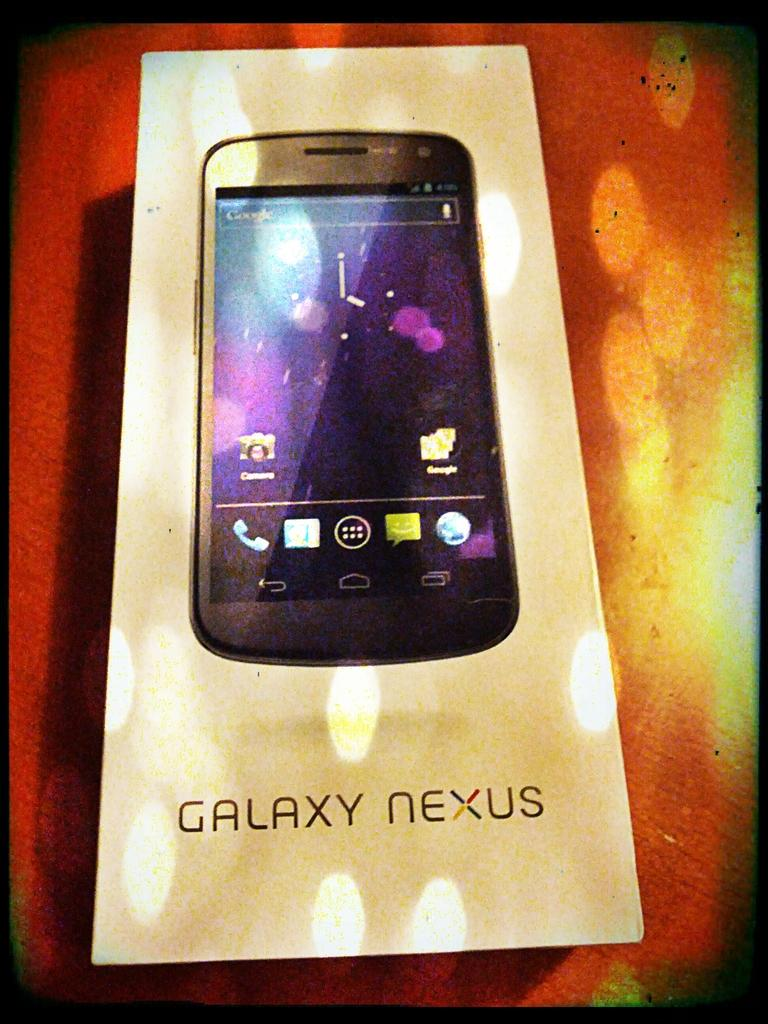<image>
Describe the image concisely. Box for Galaxy Nexus showing the phone on the front. 